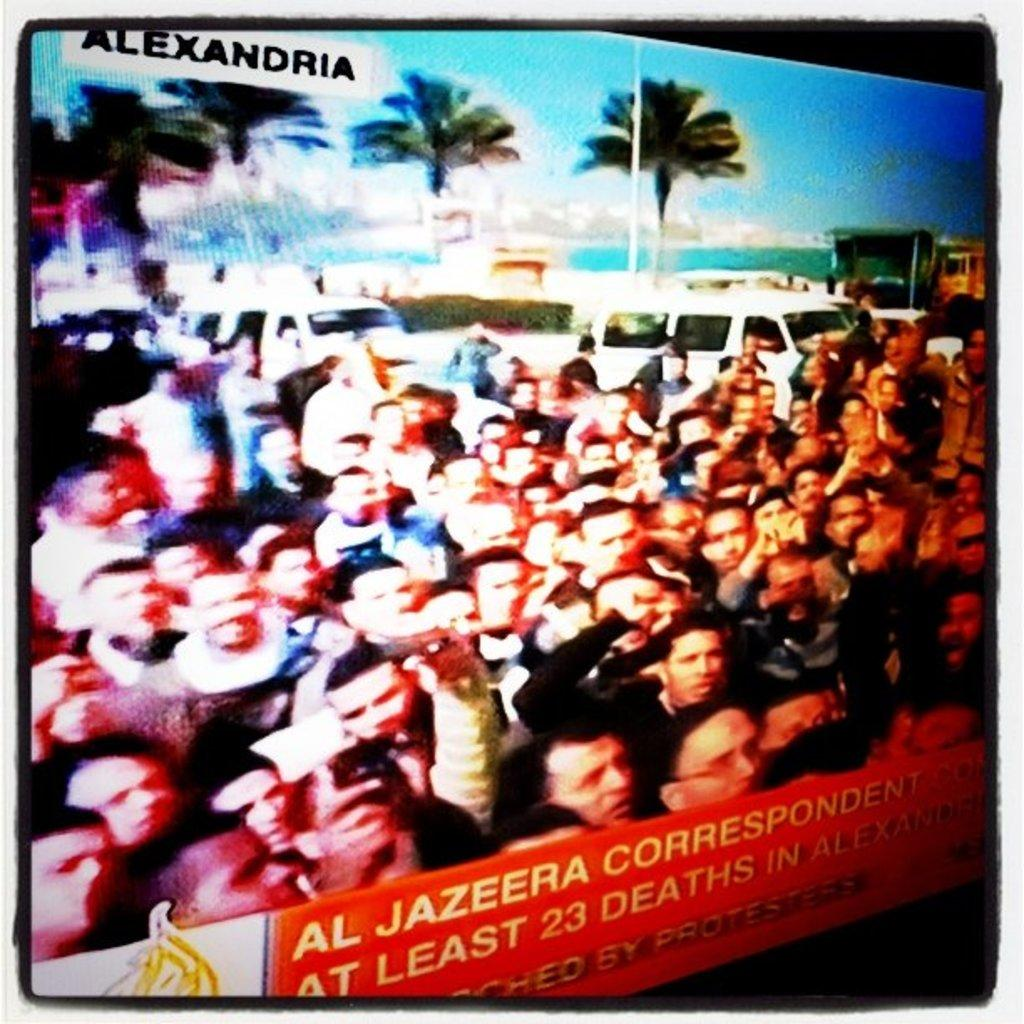<image>
Give a short and clear explanation of the subsequent image. A screen cap of an angry crowd in Alexandria on the Al Jezeera network. 